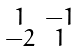Convert formula to latex. <formula><loc_0><loc_0><loc_500><loc_500>\begin{smallmatrix} 1 & - 1 \\ - 2 & 1 \end{smallmatrix}</formula> 